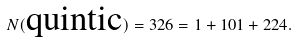Convert formula to latex. <formula><loc_0><loc_0><loc_500><loc_500>N ( \text {quintic} ) = 3 2 6 = 1 + 1 0 1 + 2 2 4 .</formula> 